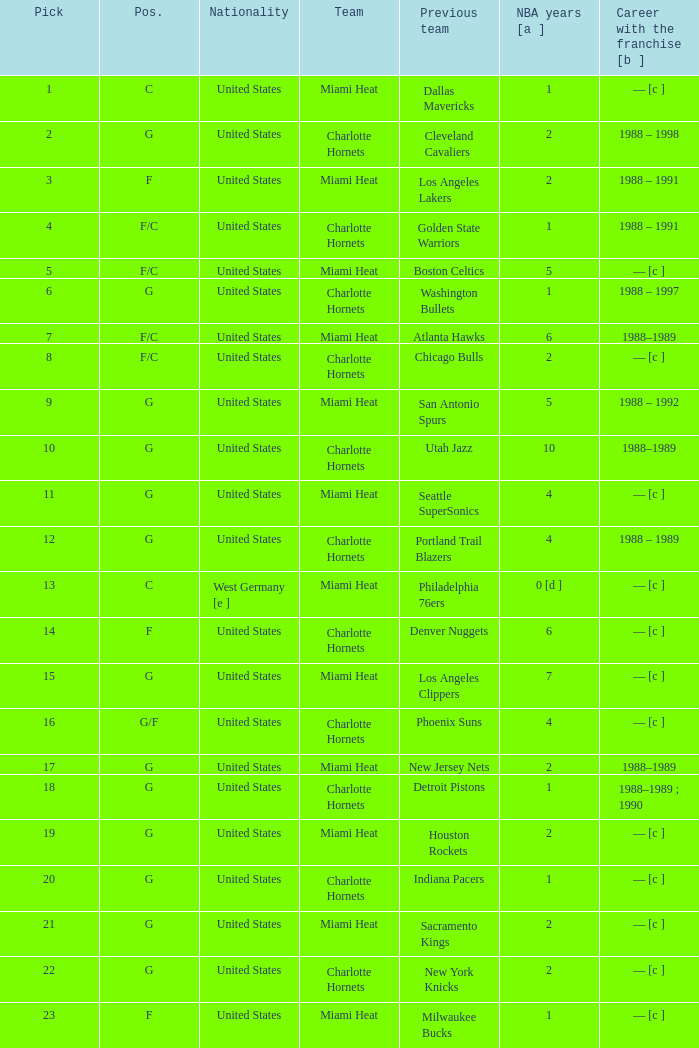What was the duration of the nba career of the us player who previously played for the los angeles lakers? 2.0. 